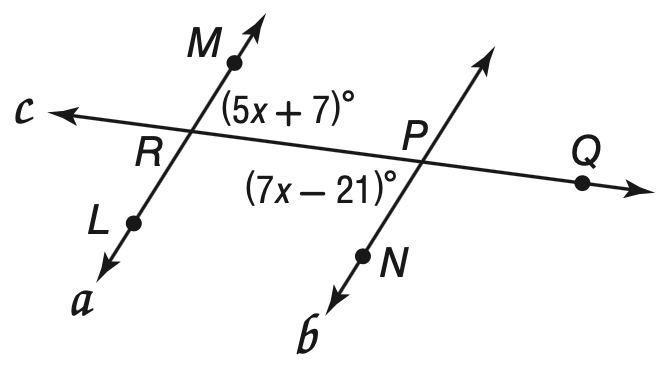Answer the mathemtical geometry problem and directly provide the correct option letter.
Question: Find m \angle M R Q so that a \parallel b.
Choices: A: 13.8 B: 14 C: 42 D: 77 D 